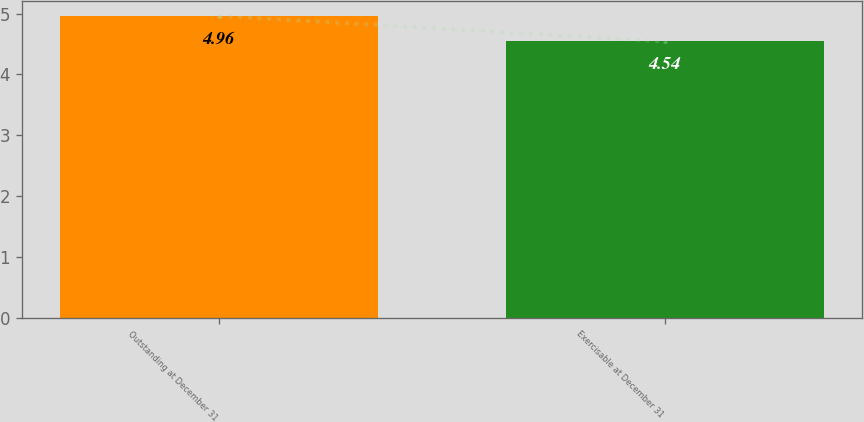Convert chart to OTSL. <chart><loc_0><loc_0><loc_500><loc_500><bar_chart><fcel>Outstanding at December 31<fcel>Exercisable at December 31<nl><fcel>4.96<fcel>4.54<nl></chart> 